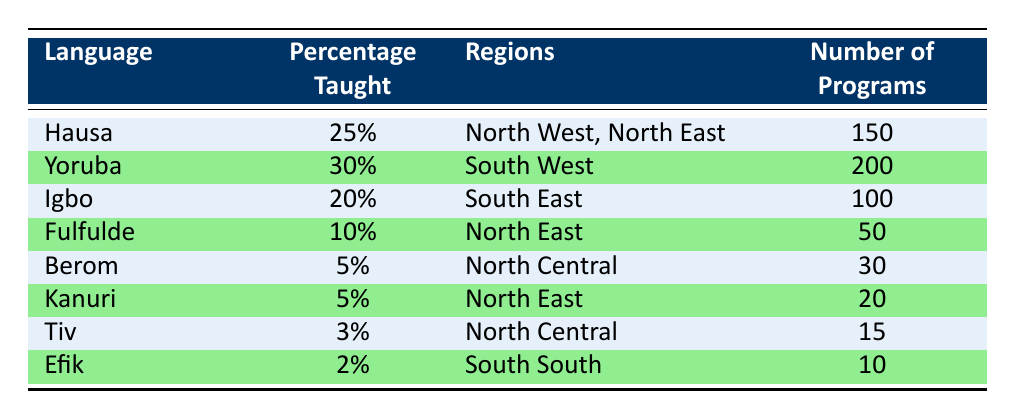What is the percentage of Yoruba taught in multicultural education programs? The table shows that Yoruba is taught in 30% of multicultural education programs, which is directly stated in the 'Percentage Taught' column for the Yoruba row.
Answer: 30% How many programs are dedicated to teaching Igbo? Referring to the table, the row for Igbo indicates that there are 100 programs dedicated to teaching this language, clearly stated in the 'Number of Programs' column.
Answer: 100 Which language has the least percentage taught, and what is that percentage? Looking at the 'Percentage Taught' column, Efik has the least at 2%. This can be confirmed by comparing all the values in that column, where Efik appears as the lowest.
Answer: Efik, 2% Are there more programs dedicated to teaching Hausa than Fulfulde? The table indicates that Hausa has 150 programs while Fulfulde has 50. To answer this question, we compare the two values from the 'Number of Programs' column. Since 150 is greater than 50, the answer is yes.
Answer: Yes What is the total percentage taught for the languages in the North East region? The languages taught in the North East region are Hausa (25%), Fulfulde (10%), and Kanuri (5%). The total percentage can be calculated by adding these values together (25 + 10 + 5 = 40). Therefore, the total percentage taught for this region is 40%.
Answer: 40% Which region has the highest number of programs associated with a particular language? By examining the 'Number of Programs' column, Yoruba has the highest number of programs with 200. This is more than any other language listed. Hence, the South West region has the highest number attributed to Yoruba.
Answer: South West, 200 Is it true that Berom has a higher percentage taught than Efik? The percentage taught for Berom is 5% while Efik is only 2%. Since 5% is greater than 2%, this statement is true.
Answer: True What is the average percentage of languages taught in the North Central region? In the North Central region, Berom is at 5% and Tiv is at 3%. The average percentage is calculated by adding these percentages (5 + 3 = 8) and dividing by the number of data points (2), resulting in an average of 4%.
Answer: 4% 